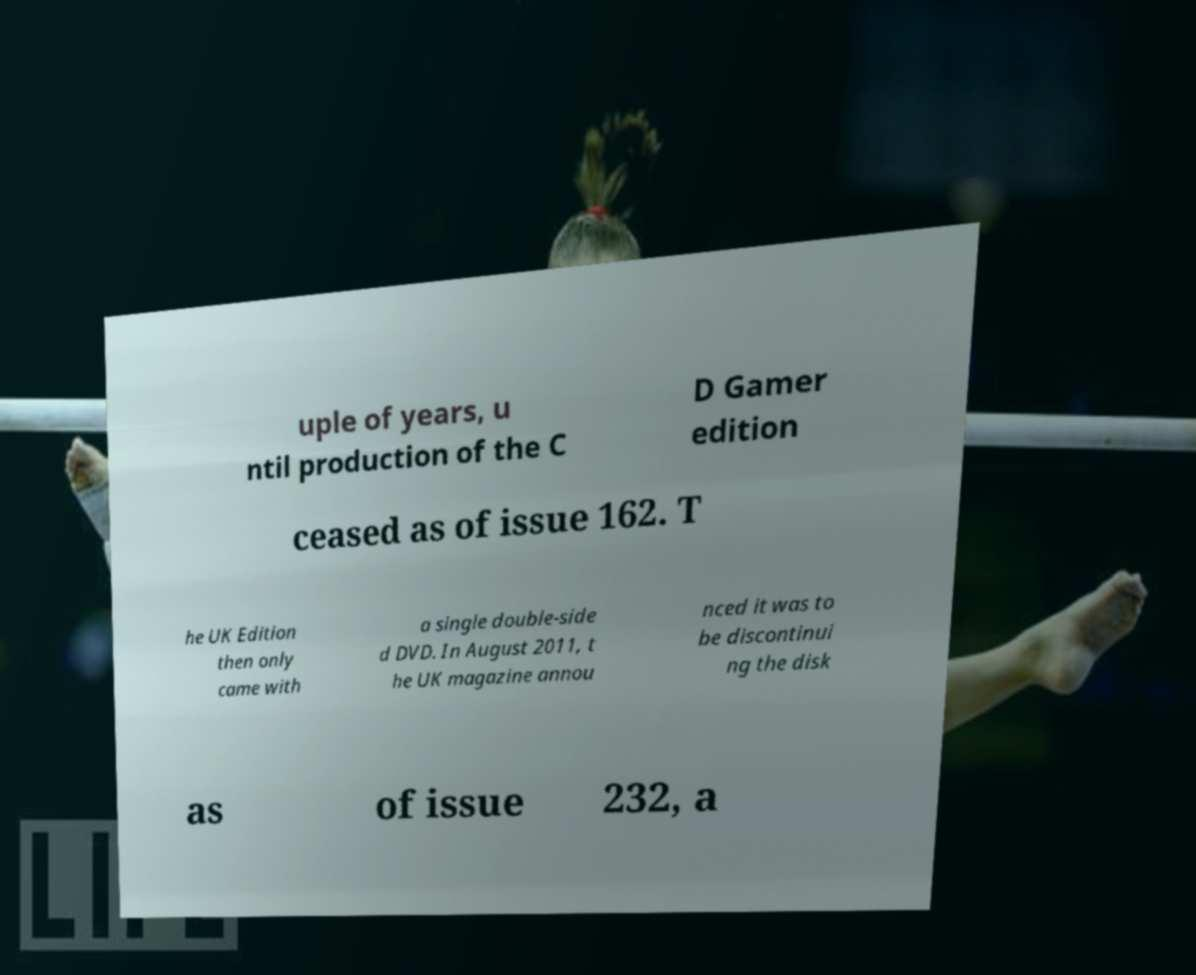Can you accurately transcribe the text from the provided image for me? uple of years, u ntil production of the C D Gamer edition ceased as of issue 162. T he UK Edition then only came with a single double-side d DVD. In August 2011, t he UK magazine annou nced it was to be discontinui ng the disk as of issue 232, a 